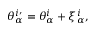<formula> <loc_0><loc_0><loc_500><loc_500>\theta _ { \alpha } ^ { i \prime } = \theta _ { \alpha } ^ { i } + \xi _ { \alpha } ^ { i } ,</formula> 